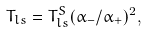<formula> <loc_0><loc_0><loc_500><loc_500>T _ { l s } = T _ { l s } ^ { S } ( \alpha _ { - } / \alpha _ { + } ) ^ { 2 } ,</formula> 